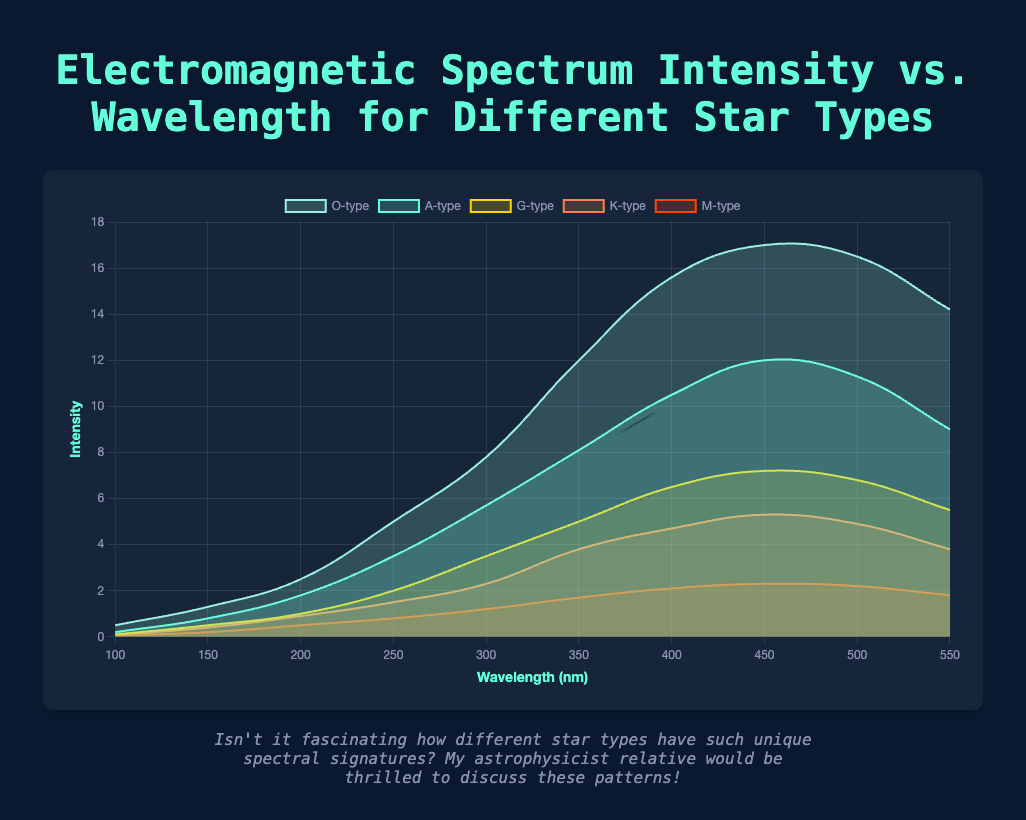What's the highest intensity recorded for an O-type star, and at what wavelength does it occur? First, identify the peak intensity value for the O-type star among the data points. The highest intensity is 17.0. The corresponding wavelength for this peak intensity is 450 nm.
Answer: 17.0 at 450 nm How does the peak intensity of an A-type star compare to the peak intensity of a G-type star? Look at the intensity values of A-type and G-type stars to find their peak intensities. The peak intensity for an A-type star is 12.0, and for a G-type star, it is 7.2. A-type stars have a higher peak intensity compared to G-type stars.
Answer: A-type is higher What is the average intensity at wavelength 400 nm for all star types? Note the intensity at 400 nm for each star type: O-type (15.6), A-type (10.5), G-type (6.5), K-type (4.7), M-type (2.1). Sum these values and divide by the number of star types: (15.6 + 10.5 + 6.5 + 4.7 + 2.1) / 5 = 39.4 / 5 = 7.88.
Answer: 7.88 Which star type has the lowest intensity value at wavelength 300 nm? Look for the intensity values at 300 nm for all star types and identify the smallest one: O-type (7.8), A-type (5.7), G-type (3.5), K-type (2.3), M-type (1.2). The lowest intensity at this wavelength is for the M-type star.
Answer: M-type At what wavelength does the intensity of the K-type star begin to decrease after increasing? Examine the intensity values for K-type stars. Observe that the intensity increases up to 450 nm (reaching 5.3) and then decreases at 500 nm (intensity 4.9).
Answer: 450 nm If you look at the slope of the intensity curve around 350 nm, which star type shows the steepest increase in intensity? Calculate the differences in intensity from 300 nm to 350 nm for all star types: O-type increases by 4.2 (12.0-7.8), A-type by 2.4 (8.1-5.7), G-type by 1.5 (5.0-3.5), K-type by 1.5 (3.8-2.3), M-type by 0.5 (1.7-1.2). The steepest increase in intensity is for the O-type star.
Answer: O-type Which star type has the most dramatic drop in intensity between wavelengths 450 nm and 550 nm? Calculate the difference in intensity between 450 nm and 550 nm for each star type: O-type drops by 2.8 (17.0-14.2), A-type by 3.0 (12.0-9.0), G-type by 1.7 (7.2-5.5), K-type by 1.5 (5.3-3.8), M-type by 0.5 (2.3-1.8). The most dramatic drop is for the A-type star.
Answer: A-type What is the total intensity sum for the M-type star across all wavelengths? Sum the intensity values for M-type across all wavelengths: 0.05 + 0.2 + 0.5 + 0.8 + 1.2 + 1.7 + 2.1 + 2.3 + 2.2 + 1.8 = 12.85.
Answer: 12.85 Which star type has the narrowest spectral peak width around its highest intensity? Identify the wavelength range around the peak intensity for each star type. O-type (450 nm, narrow), A-type (450 nm, narrow), G-type (450 nm, narrow), K-type (450 nm, narrow), M-type (450 nm, narrow). All types have peaks around 450 nm, but narrow spectral peaks indicate the same wavelength (450 nm) serves as the center for most star types' highest intensity.
Answer: O-type, A-type, G-type, K-type, M-type 